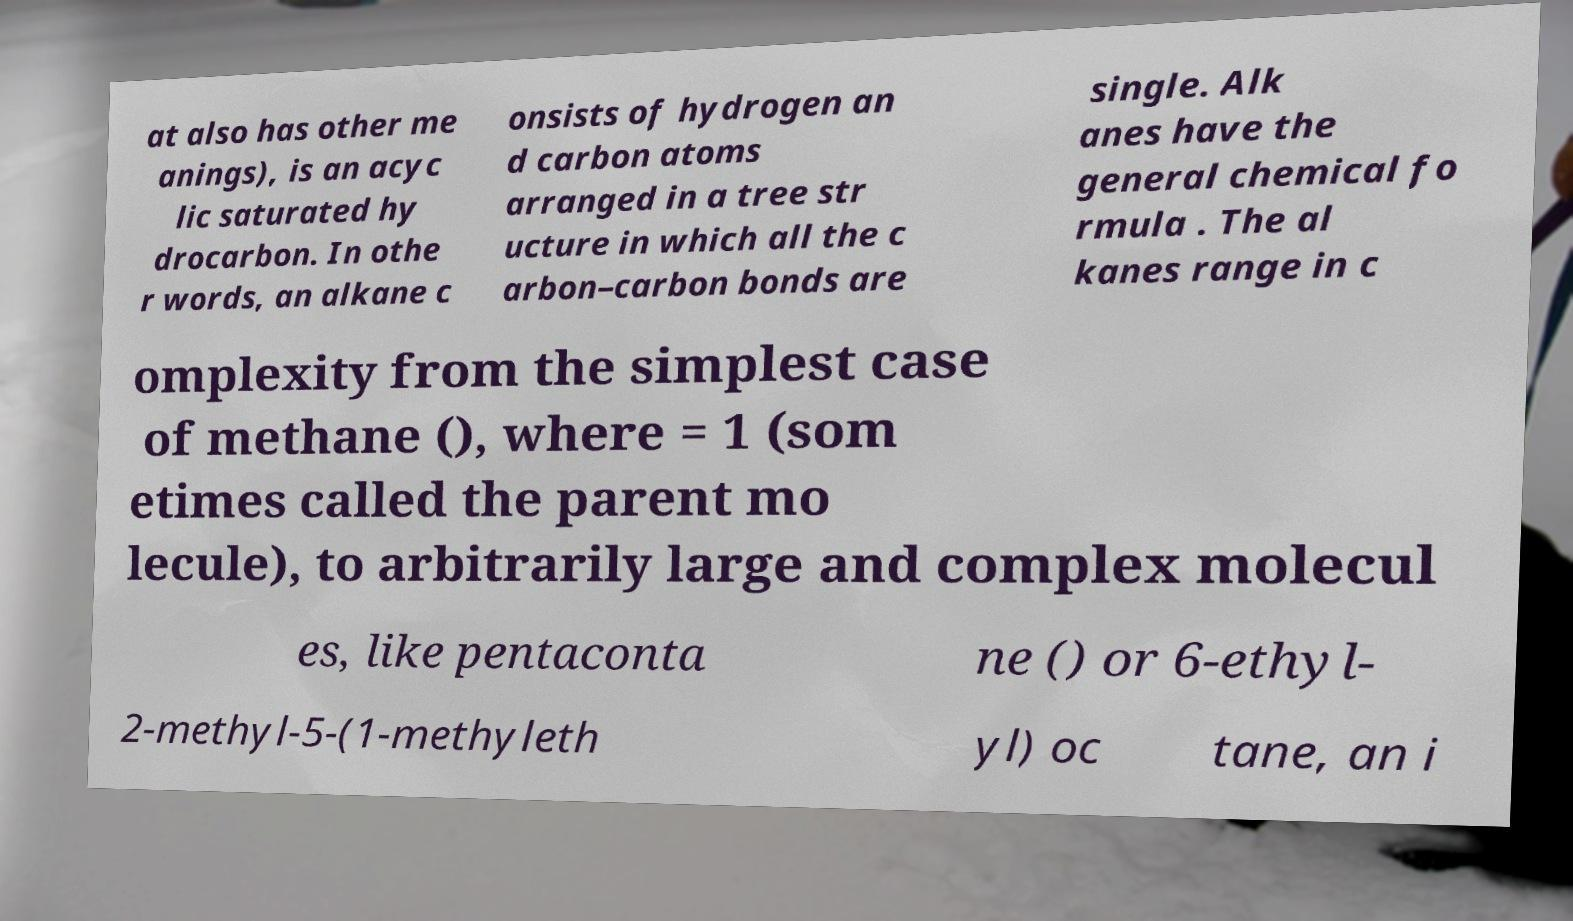There's text embedded in this image that I need extracted. Can you transcribe it verbatim? at also has other me anings), is an acyc lic saturated hy drocarbon. In othe r words, an alkane c onsists of hydrogen an d carbon atoms arranged in a tree str ucture in which all the c arbon–carbon bonds are single. Alk anes have the general chemical fo rmula . The al kanes range in c omplexity from the simplest case of methane (), where = 1 (som etimes called the parent mo lecule), to arbitrarily large and complex molecul es, like pentaconta ne () or 6-ethyl- 2-methyl-5-(1-methyleth yl) oc tane, an i 